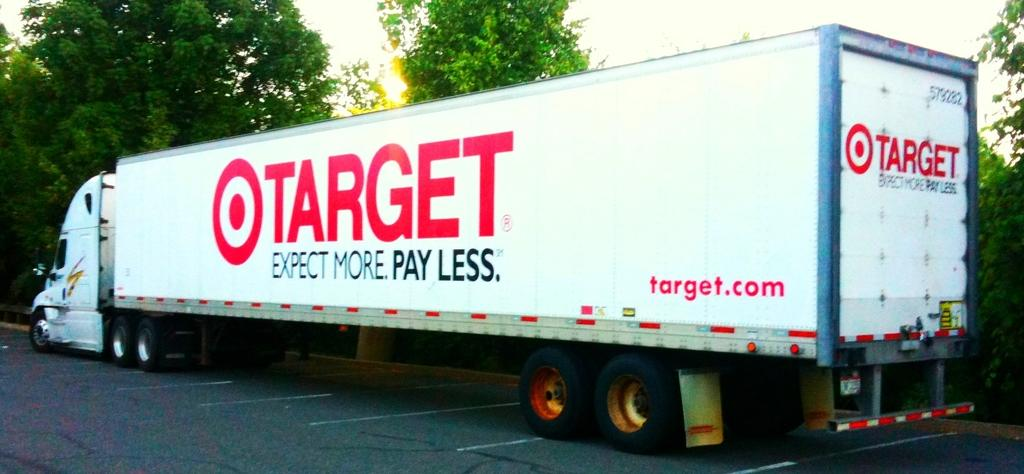What is located at the bottom of the image? There is a road at the bottom of the image. What can be seen in the middle of the image? There are trees and a truck in the middle of the image. What is visible at the top of the image? The sky is visible at the top of the image. How many boards are stacked on the truck in the image? There are no boards visible on the truck in the image. What type of trouble is the truck experiencing in the image? There is no indication of any trouble with the truck in the image; it appears to be parked or driving normally. 